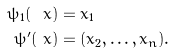<formula> <loc_0><loc_0><loc_500><loc_500>\psi _ { 1 } ( \ x ) & = x _ { 1 } \\ \psi ^ { \prime } ( \ x ) & = ( x _ { 2 } , \dots , x _ { n } ) .</formula> 